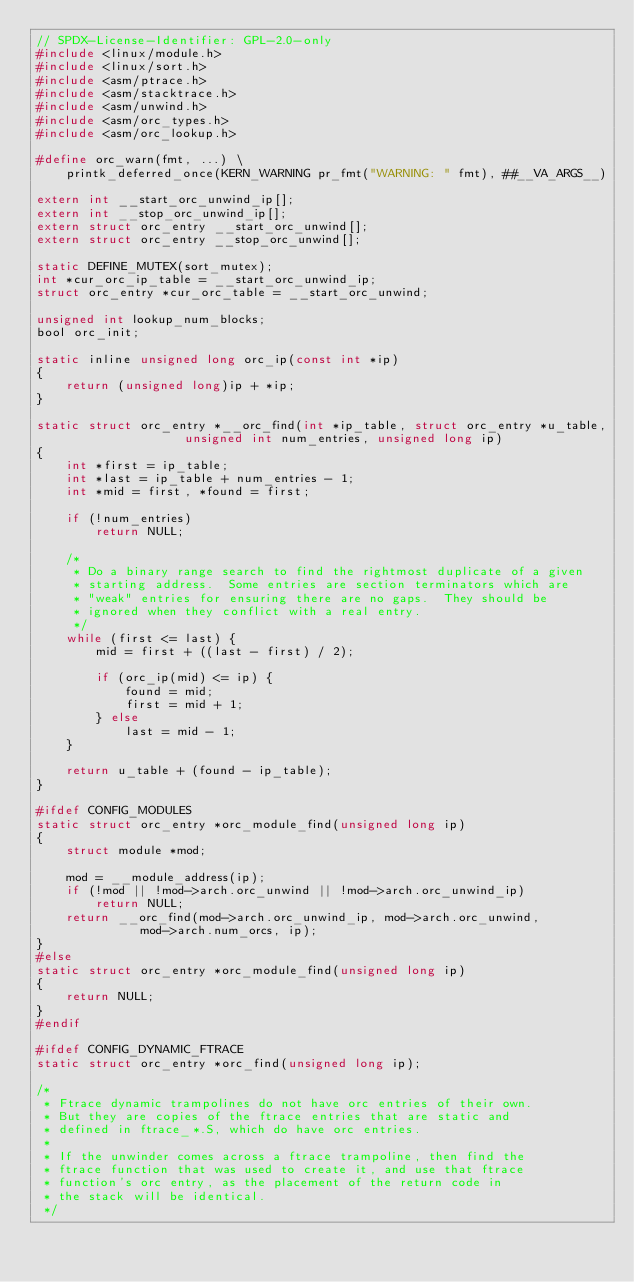<code> <loc_0><loc_0><loc_500><loc_500><_C_>// SPDX-License-Identifier: GPL-2.0-only
#include <linux/module.h>
#include <linux/sort.h>
#include <asm/ptrace.h>
#include <asm/stacktrace.h>
#include <asm/unwind.h>
#include <asm/orc_types.h>
#include <asm/orc_lookup.h>

#define orc_warn(fmt, ...) \
	printk_deferred_once(KERN_WARNING pr_fmt("WARNING: " fmt), ##__VA_ARGS__)

extern int __start_orc_unwind_ip[];
extern int __stop_orc_unwind_ip[];
extern struct orc_entry __start_orc_unwind[];
extern struct orc_entry __stop_orc_unwind[];

static DEFINE_MUTEX(sort_mutex);
int *cur_orc_ip_table = __start_orc_unwind_ip;
struct orc_entry *cur_orc_table = __start_orc_unwind;

unsigned int lookup_num_blocks;
bool orc_init;

static inline unsigned long orc_ip(const int *ip)
{
	return (unsigned long)ip + *ip;
}

static struct orc_entry *__orc_find(int *ip_table, struct orc_entry *u_table,
				    unsigned int num_entries, unsigned long ip)
{
	int *first = ip_table;
	int *last = ip_table + num_entries - 1;
	int *mid = first, *found = first;

	if (!num_entries)
		return NULL;

	/*
	 * Do a binary range search to find the rightmost duplicate of a given
	 * starting address.  Some entries are section terminators which are
	 * "weak" entries for ensuring there are no gaps.  They should be
	 * ignored when they conflict with a real entry.
	 */
	while (first <= last) {
		mid = first + ((last - first) / 2);

		if (orc_ip(mid) <= ip) {
			found = mid;
			first = mid + 1;
		} else
			last = mid - 1;
	}

	return u_table + (found - ip_table);
}

#ifdef CONFIG_MODULES
static struct orc_entry *orc_module_find(unsigned long ip)
{
	struct module *mod;

	mod = __module_address(ip);
	if (!mod || !mod->arch.orc_unwind || !mod->arch.orc_unwind_ip)
		return NULL;
	return __orc_find(mod->arch.orc_unwind_ip, mod->arch.orc_unwind,
			  mod->arch.num_orcs, ip);
}
#else
static struct orc_entry *orc_module_find(unsigned long ip)
{
	return NULL;
}
#endif

#ifdef CONFIG_DYNAMIC_FTRACE
static struct orc_entry *orc_find(unsigned long ip);

/*
 * Ftrace dynamic trampolines do not have orc entries of their own.
 * But they are copies of the ftrace entries that are static and
 * defined in ftrace_*.S, which do have orc entries.
 *
 * If the unwinder comes across a ftrace trampoline, then find the
 * ftrace function that was used to create it, and use that ftrace
 * function's orc entry, as the placement of the return code in
 * the stack will be identical.
 */</code> 